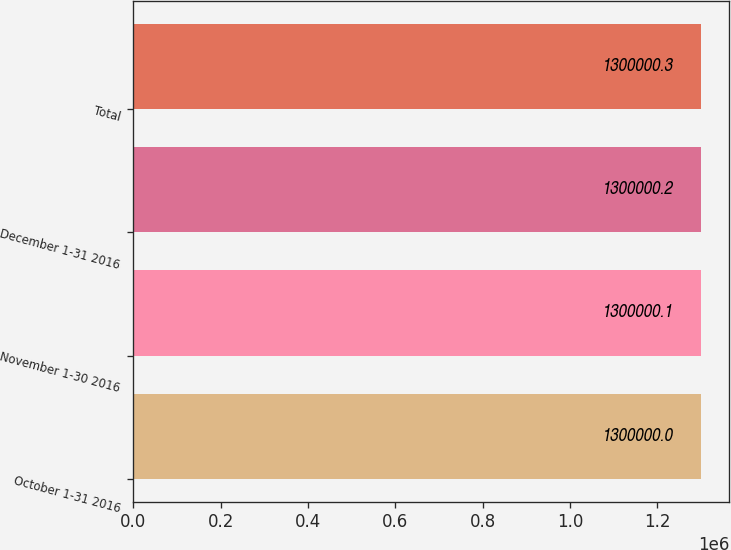Convert chart. <chart><loc_0><loc_0><loc_500><loc_500><bar_chart><fcel>October 1-31 2016<fcel>November 1-30 2016<fcel>December 1-31 2016<fcel>Total<nl><fcel>1.3e+06<fcel>1.3e+06<fcel>1.3e+06<fcel>1.3e+06<nl></chart> 